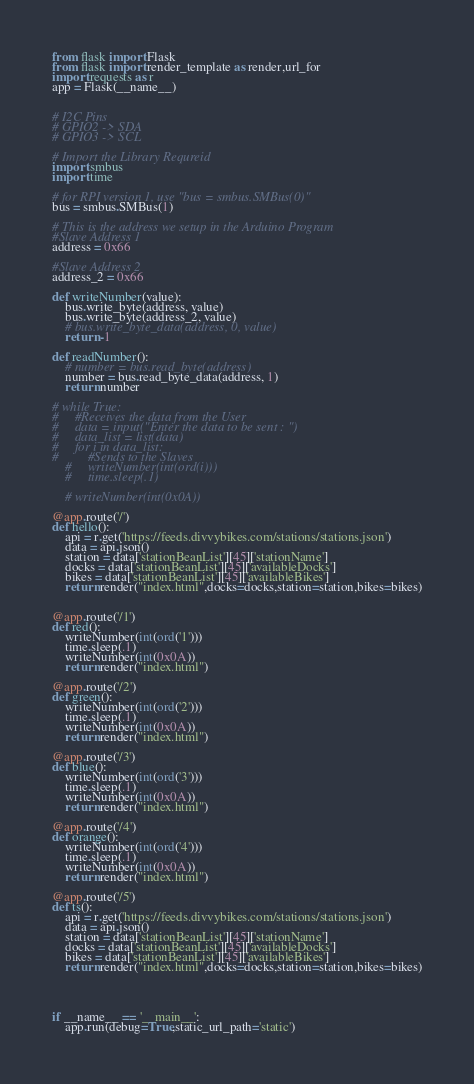Convert code to text. <code><loc_0><loc_0><loc_500><loc_500><_Python_>from flask import Flask
from flask import render_template as render,url_for
import requests as r
app = Flask(__name__)


# I2C Pins 
# GPIO2 -> SDA
# GPIO3 -> SCL

# Import the Library Requreid 
import smbus
import time

# for RPI version 1, use "bus = smbus.SMBus(0)"
bus = smbus.SMBus(1)

# This is the address we setup in the Arduino Program
#Slave Address 1
address = 0x66

#Slave Address 2
address_2 = 0x66

def writeNumber(value):
    bus.write_byte(address, value)
    bus.write_byte(address_2, value)
    # bus.write_byte_data(address, 0, value)
    return -1

def readNumber():
    # number = bus.read_byte(address)
    number = bus.read_byte_data(address, 1)
    return number
    
# while True:
#     #Receives the data from the User
#     data = input("Enter the data to be sent : ")
#     data_list = list(data)
#     for i in data_list:
#         #Sends to the Slaves 
    #     writeNumber(int(ord(i)))
    #     time.sleep(.1)

    # writeNumber(int(0x0A))

@app.route('/')
def hello():
	api = r.get('https://feeds.divvybikes.com/stations/stations.json')
	data = api.json()
	station = data['stationBeanList'][45]['stationName']
	docks = data['stationBeanList'][45]['availableDocks']
	bikes = data['stationBeanList'][45]['availableBikes']
	return render("index.html",docks=docks,station=station,bikes=bikes)


@app.route('/1')
def red():
	writeNumber(int(ord('1')))
	time.sleep(.1)
	writeNumber(int(0x0A))
	return render("index.html")

@app.route('/2')
def green():
	writeNumber(int(ord('2')))
	time.sleep(.1)
	writeNumber(int(0x0A))
	return render("index.html")

@app.route('/3')
def blue():
	writeNumber(int(ord('3')))
	time.sleep(.1)
	writeNumber(int(0x0A))
	return render("index.html")

@app.route('/4')
def orange():
	writeNumber(int(ord('4')))
	time.sleep(.1)
	writeNumber(int(0x0A))
	return render("index.html")

@app.route('/5')
def ts():
	api = r.get('https://feeds.divvybikes.com/stations/stations.json')
	data = api.json()
	station = data['stationBeanList'][45]['stationName']
	docks = data['stationBeanList'][45]['availableDocks']
	bikes = data['stationBeanList'][45]['availableBikes']
	return render("index.html",docks=docks,station=station,bikes=bikes)




if __name__ == '__main__':
	app.run(debug=True,static_url_path='static')</code> 